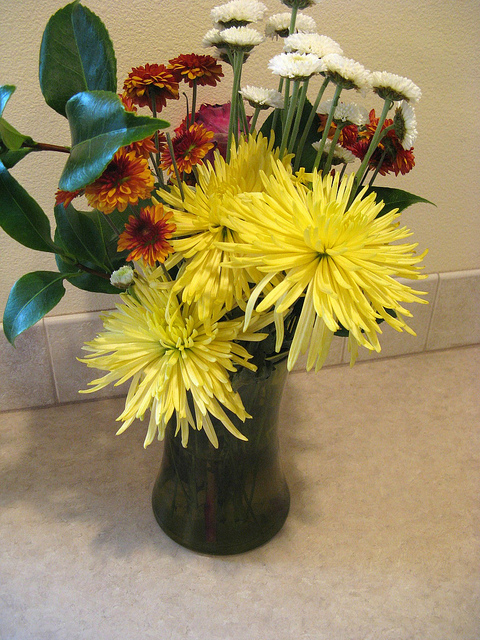<image>Who bought the flowers? I don't know who bought the flowers. It can be a friend, spouse, or husband. Who bought the flowers? I am not sure who bought the flowers. It could be no one, a friend, a spouse, or the owner of the vase. 